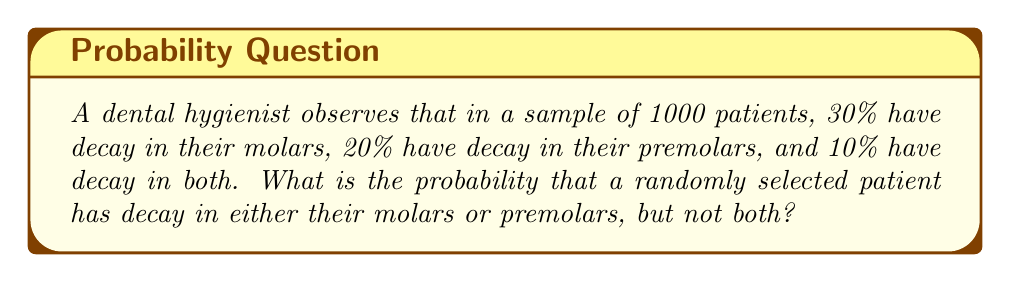Provide a solution to this math problem. Let's approach this step-by-step using probability theory:

1) Let M be the event of molar decay and P be the event of premolar decay.

2) Given:
   P(M) = 30% = 0.3
   P(P) = 20% = 0.2
   P(M ∩ P) = 10% = 0.1

3) We need to find P(M ∪ P) - P(M ∩ P)

4) First, let's calculate P(M ∪ P) using the addition rule of probability:
   P(M ∪ P) = P(M) + P(P) - P(M ∩ P)
   
   P(M ∪ P) = 0.3 + 0.2 - 0.1 = 0.4

5) Now, we can calculate the probability of decay in either molars or premolars, but not both:
   P((M ∪ P) - (M ∩ P)) = P(M ∪ P) - P(M ∩ P)
                        = 0.4 - 0.1
                        = 0.3

6) Therefore, the probability is 0.3 or 30%.

This can be visualized using a Venn diagram:

[asy]
unitsize(1cm);
pair A=(0,0), B=(2,0);
real r=1.2;
path c1=circle(A,r), c2=circle(B,r);
fill(c1,rgb(0.9,0.9,1));
fill(c2,rgb(0.9,1,0.9));
fill(c1,rgb(0.8,1,1) and c2);
draw(c1);
draw(c2);
label("M", A+(-0.5,0.5));
label("P", B+(0.5,0.5));
label("0.2", A+(-0.5,-0.5));
label("0.1", B+(0.5,-0.5));
label("0.1", (1,0));
[/asy]

The shaded areas (light blue and light green, excluding the overlap) represent the probability we calculated.
Answer: 0.3 